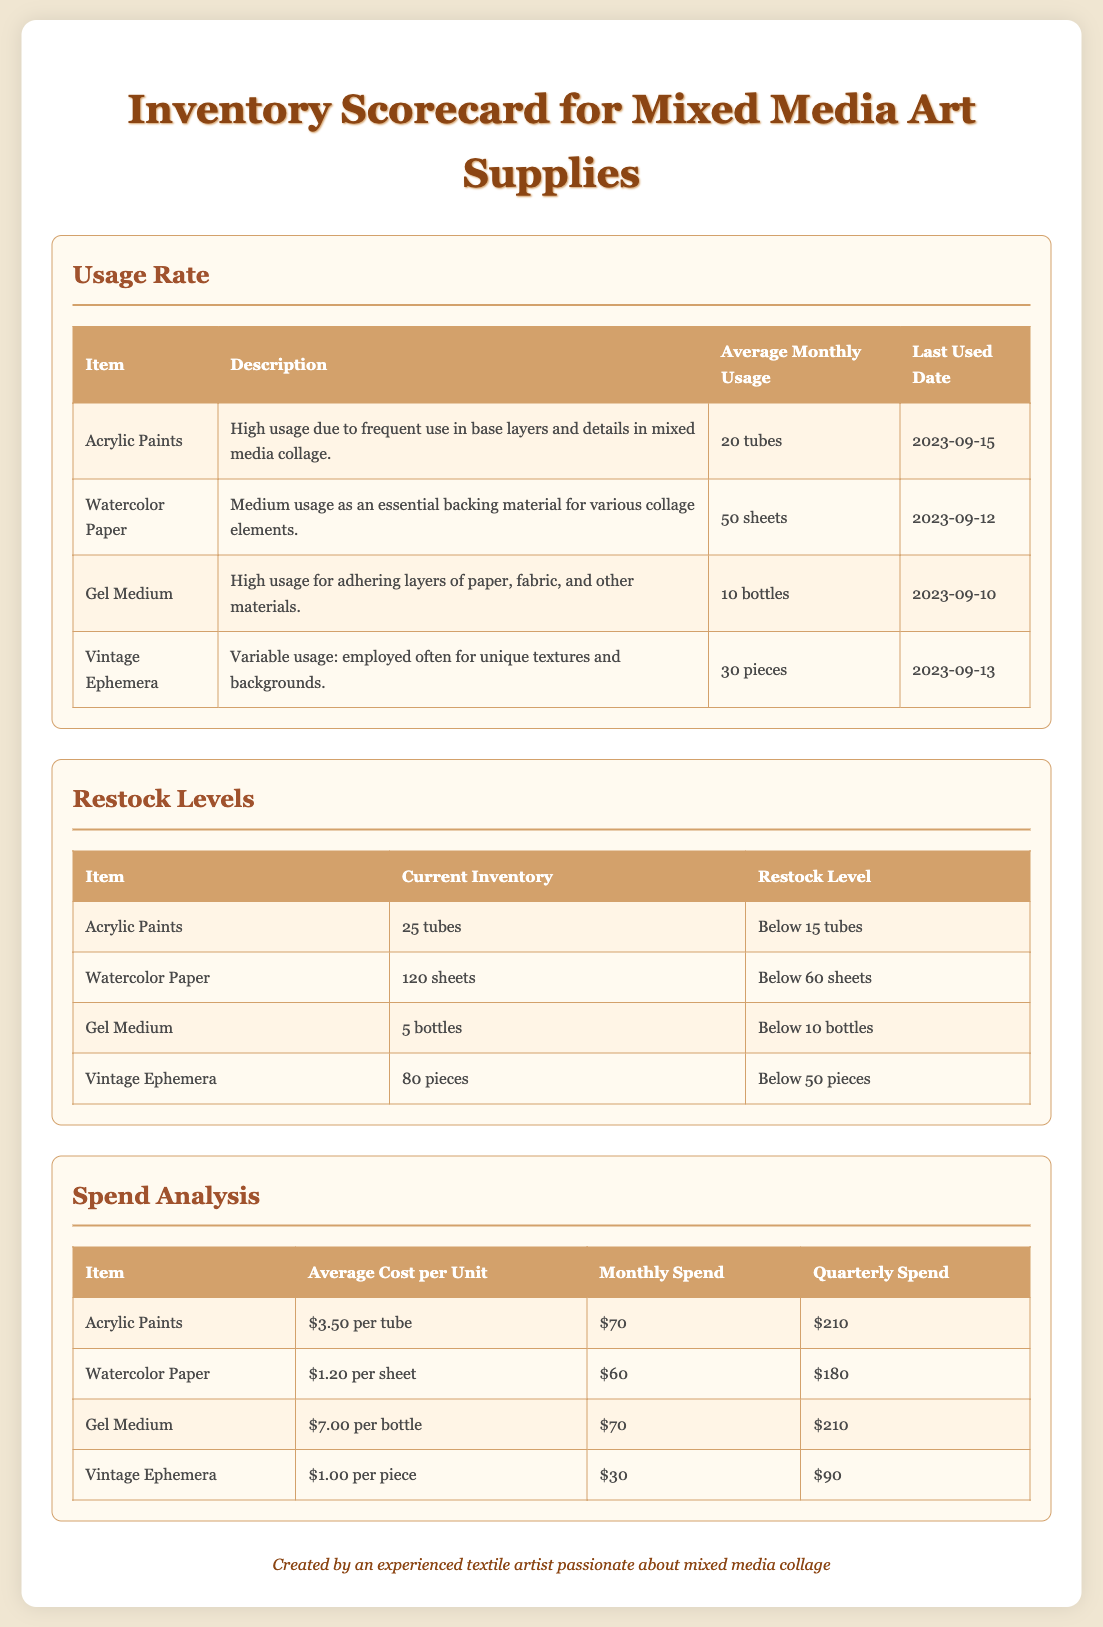What is the average monthly usage of Acrylic Paints? The average monthly usage of Acrylic Paints is listed in the Usage Rate section.
Answer: 20 tubes What is the last used date for Watercolor Paper? The last used date for Watercolor Paper is found in the Usage Rate section.
Answer: 2023-09-12 What is the current inventory of Gel Medium? The current inventory of Gel Medium can be found in the Restock Levels section.
Answer: 5 bottles What is the average cost per unit of Vintage Ephemera? The average cost per unit of Vintage Ephemera is listed in the Spend Analysis section.
Answer: $1.00 per piece What is the monthly spend on Watercolor Paper? The monthly spend on Watercolor Paper is detailed in the Spend Analysis section.
Answer: $60 Which item has a restock level below 15 tubes? The restock levels are specified in the Restock Levels section for each item.
Answer: Acrylic Paints What is the description of Vintage Ephemera? The description of Vintage Ephemera is given in the Usage Rate section.
Answer: Variable usage: employed often for unique textures and backgrounds How many pieces of Vintage Ephemera need to be restocked? To find out how many pieces should be restocked, compare the current inventory to the restock level in the Restock Levels section.
Answer: 50 pieces 